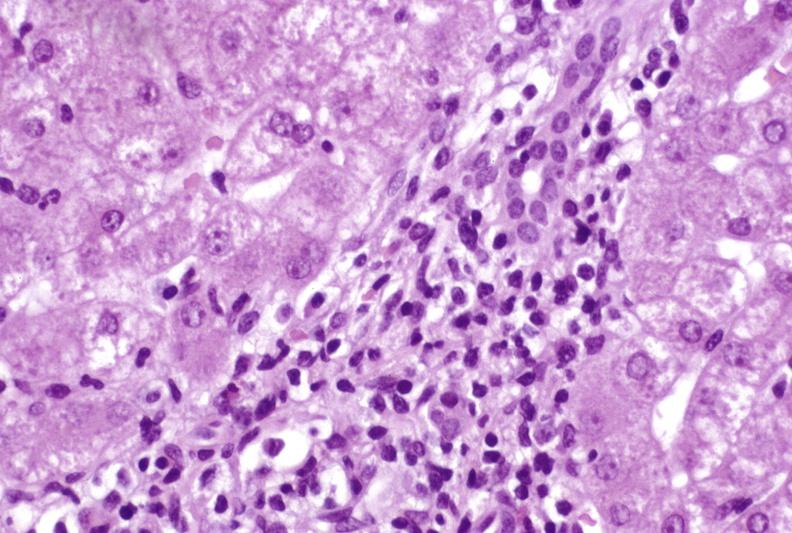what is present?
Answer the question using a single word or phrase. Liver 